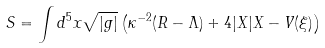<formula> <loc_0><loc_0><loc_500><loc_500>S = \int d ^ { 5 } x \sqrt { | g | } \left ( \kappa ^ { - 2 } ( R - \Lambda ) + 4 | X | X - V ( \xi ) \right )</formula> 